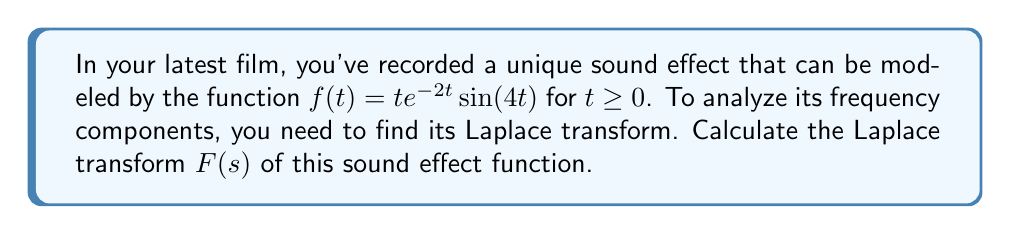Teach me how to tackle this problem. Let's approach this step-by-step:

1) The Laplace transform of $f(t)$ is defined as:

   $$F(s) = \int_0^{\infty} f(t)e^{-st}dt$$

2) Substituting our function:

   $$F(s) = \int_0^{\infty} te^{-2t}\sin(4t)e^{-st}dt$$

3) Simplify the integrand:

   $$F(s) = \int_0^{\infty} te^{-(s+2)t}\sin(4t)dt$$

4) This integral can be solved using the following property of Laplace transforms:

   If $F(s) = \mathcal{L}\{f(t)\}$, then $\mathcal{L}\{tf(t)\} = -\frac{d}{ds}F(s)$

5) Let $g(t) = e^{-2t}\sin(4t)$. We need to find $\mathcal{L}\{g(t)\}$ first:

   $$G(s) = \mathcal{L}\{e^{-2t}\sin(4t)\} = \frac{4}{(s+2)^2 + 4^2} = \frac{4}{(s+2)^2 + 16}$$

6) Now, our original function $f(t) = tg(t)$, so:

   $$F(s) = -\frac{d}{ds}G(s+2) = -\frac{d}{ds}\left(\frac{4}{s^2 + 16}\right)$$

7) Differentiate:

   $$F(s) = -\left(\frac{-8s}{(s^2 + 16)^2}\right) = \frac{8s}{(s^2 + 16)^2}$$

8) This is the Laplace transform of our sound effect function.
Answer: $$F(s) = \frac{8s}{(s^2 + 16)^2}$$ 